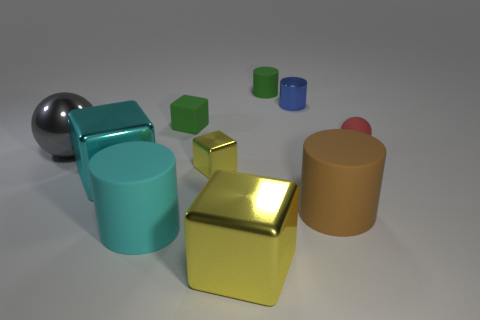There is a small cube behind the red thing; does it have the same color as the matte sphere?
Give a very brief answer. No. What shape is the thing that is the same color as the small matte block?
Ensure brevity in your answer.  Cylinder. How many tiny red objects are made of the same material as the small blue cylinder?
Provide a short and direct response. 0. There is a large yellow object; how many cylinders are behind it?
Give a very brief answer. 4. What is the size of the red thing?
Make the answer very short. Small. There is a cylinder that is the same size as the brown matte thing; what is its color?
Your answer should be very brief. Cyan. Is there a tiny cube of the same color as the metal cylinder?
Your answer should be compact. No. What is the small blue thing made of?
Provide a short and direct response. Metal. How many large gray shiny objects are there?
Ensure brevity in your answer.  1. There is a block that is in front of the cyan cube; is it the same color as the tiny shiny object behind the tiny yellow block?
Your answer should be compact. No. 